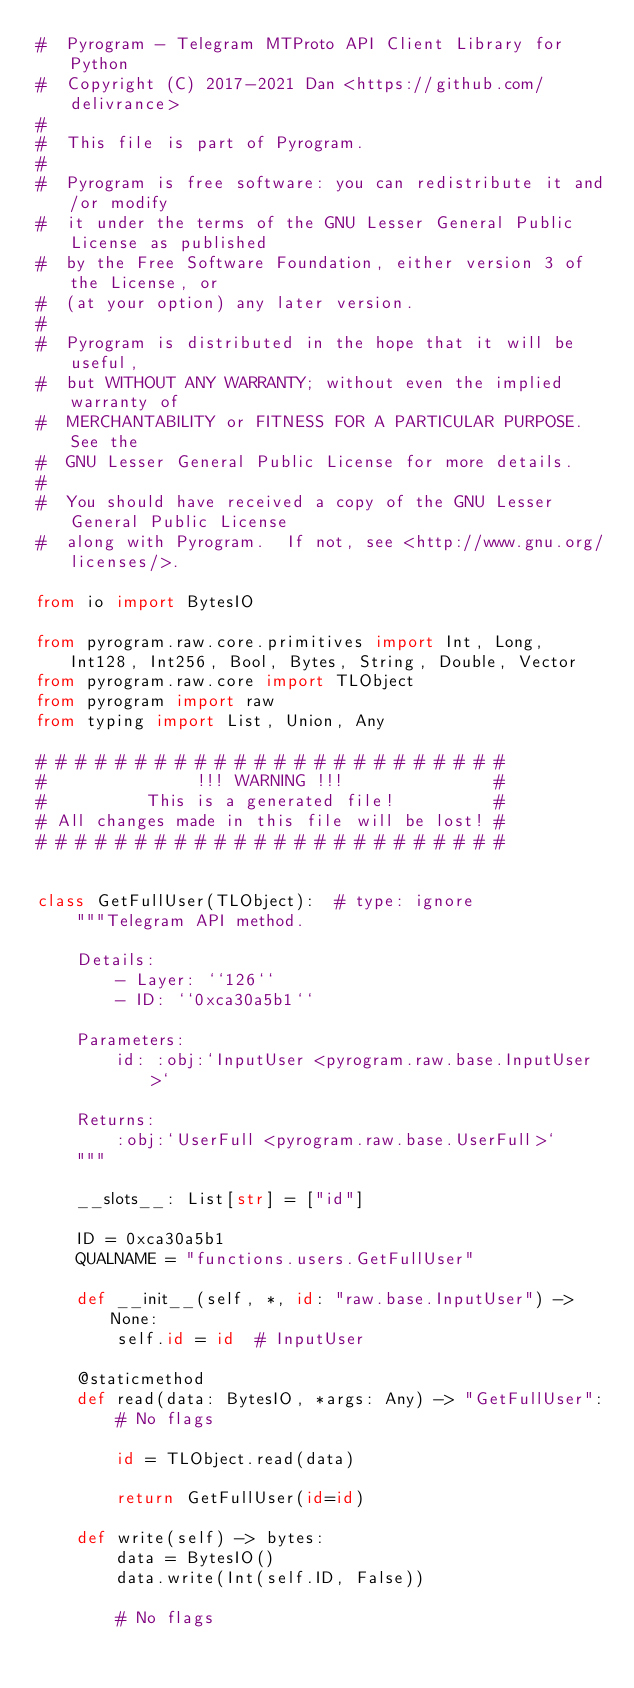<code> <loc_0><loc_0><loc_500><loc_500><_Python_>#  Pyrogram - Telegram MTProto API Client Library for Python
#  Copyright (C) 2017-2021 Dan <https://github.com/delivrance>
#
#  This file is part of Pyrogram.
#
#  Pyrogram is free software: you can redistribute it and/or modify
#  it under the terms of the GNU Lesser General Public License as published
#  by the Free Software Foundation, either version 3 of the License, or
#  (at your option) any later version.
#
#  Pyrogram is distributed in the hope that it will be useful,
#  but WITHOUT ANY WARRANTY; without even the implied warranty of
#  MERCHANTABILITY or FITNESS FOR A PARTICULAR PURPOSE.  See the
#  GNU Lesser General Public License for more details.
#
#  You should have received a copy of the GNU Lesser General Public License
#  along with Pyrogram.  If not, see <http://www.gnu.org/licenses/>.

from io import BytesIO

from pyrogram.raw.core.primitives import Int, Long, Int128, Int256, Bool, Bytes, String, Double, Vector
from pyrogram.raw.core import TLObject
from pyrogram import raw
from typing import List, Union, Any

# # # # # # # # # # # # # # # # # # # # # # # #
#               !!! WARNING !!!               #
#          This is a generated file!          #
# All changes made in this file will be lost! #
# # # # # # # # # # # # # # # # # # # # # # # #


class GetFullUser(TLObject):  # type: ignore
    """Telegram API method.

    Details:
        - Layer: ``126``
        - ID: ``0xca30a5b1``

    Parameters:
        id: :obj:`InputUser <pyrogram.raw.base.InputUser>`

    Returns:
        :obj:`UserFull <pyrogram.raw.base.UserFull>`
    """

    __slots__: List[str] = ["id"]

    ID = 0xca30a5b1
    QUALNAME = "functions.users.GetFullUser"

    def __init__(self, *, id: "raw.base.InputUser") -> None:
        self.id = id  # InputUser

    @staticmethod
    def read(data: BytesIO, *args: Any) -> "GetFullUser":
        # No flags
        
        id = TLObject.read(data)
        
        return GetFullUser(id=id)

    def write(self) -> bytes:
        data = BytesIO()
        data.write(Int(self.ID, False))

        # No flags
        </code> 